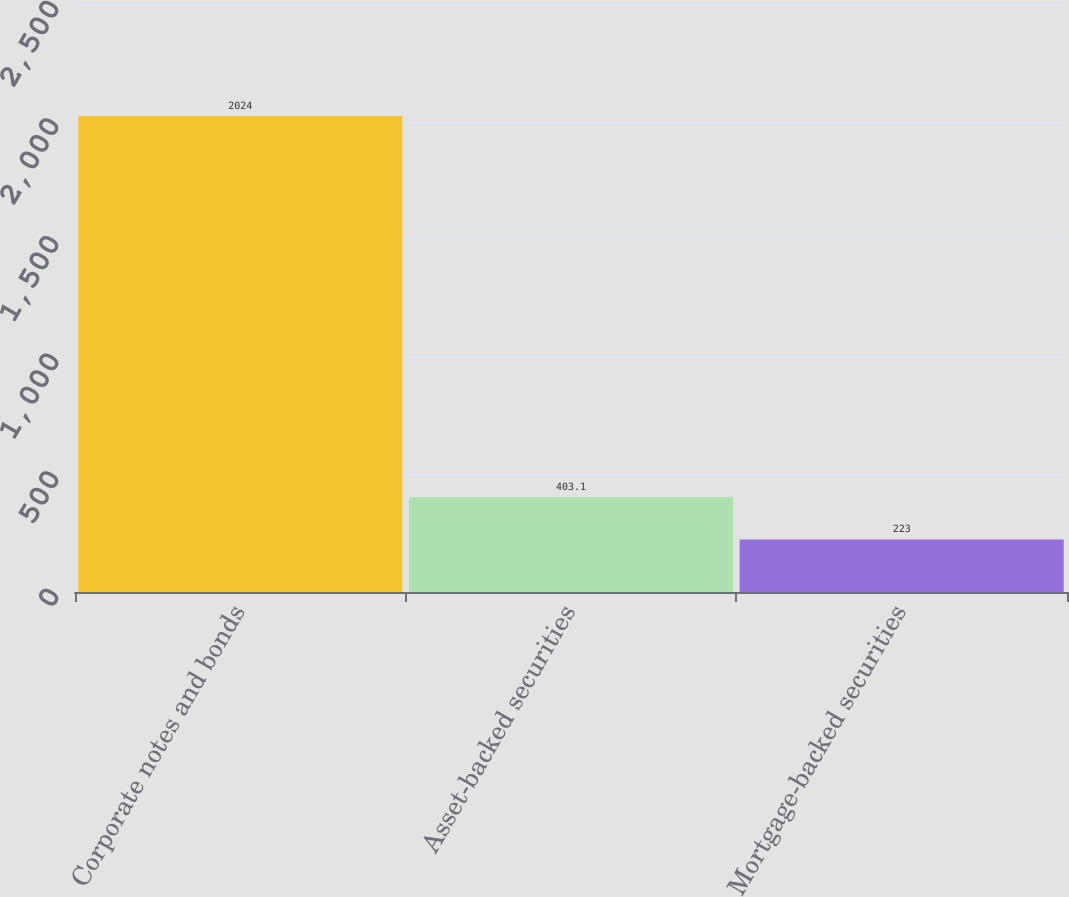<chart> <loc_0><loc_0><loc_500><loc_500><bar_chart><fcel>Corporate notes and bonds<fcel>Asset-backed securities<fcel>Mortgage-backed securities<nl><fcel>2024<fcel>403.1<fcel>223<nl></chart> 